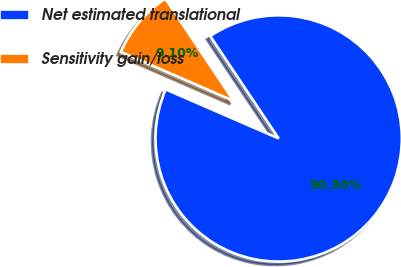Convert chart. <chart><loc_0><loc_0><loc_500><loc_500><pie_chart><fcel>Net estimated translational<fcel>Sensitivity gain/loss<nl><fcel>90.9%<fcel>9.1%<nl></chart> 